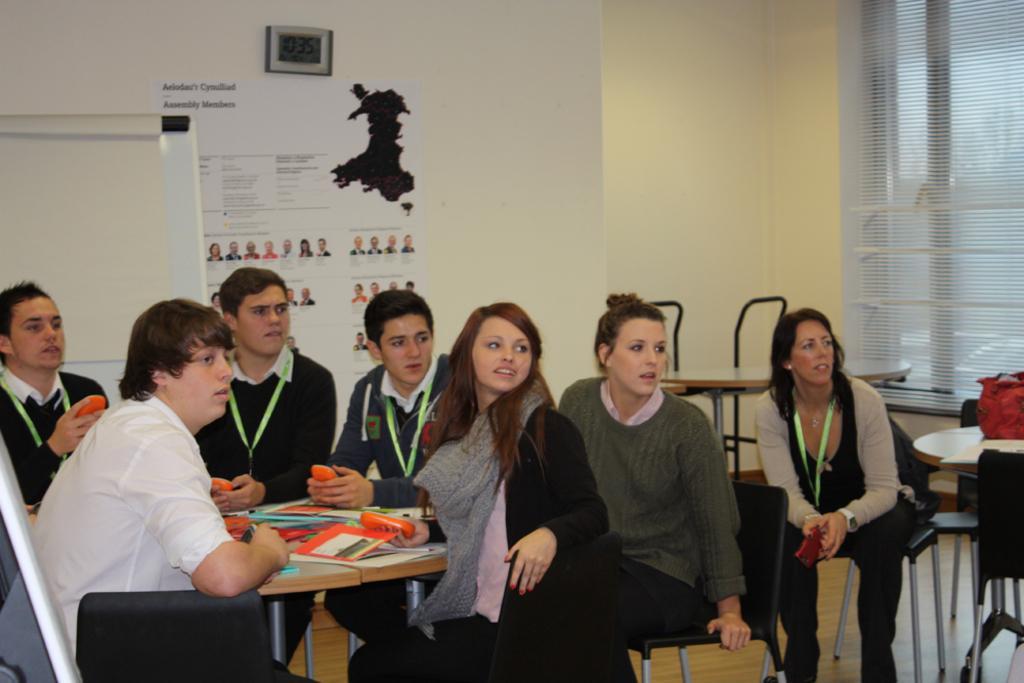Could you give a brief overview of what you see in this image? In this image I can see group of people sitting on the chairs. Few are in front of the table. On the table there are books. And people are holding orange color object. One person is wearing the grey color scarf. In the back there is a board and paper is attached to the wall. 